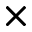<formula> <loc_0><loc_0><loc_500><loc_500>\times</formula> 